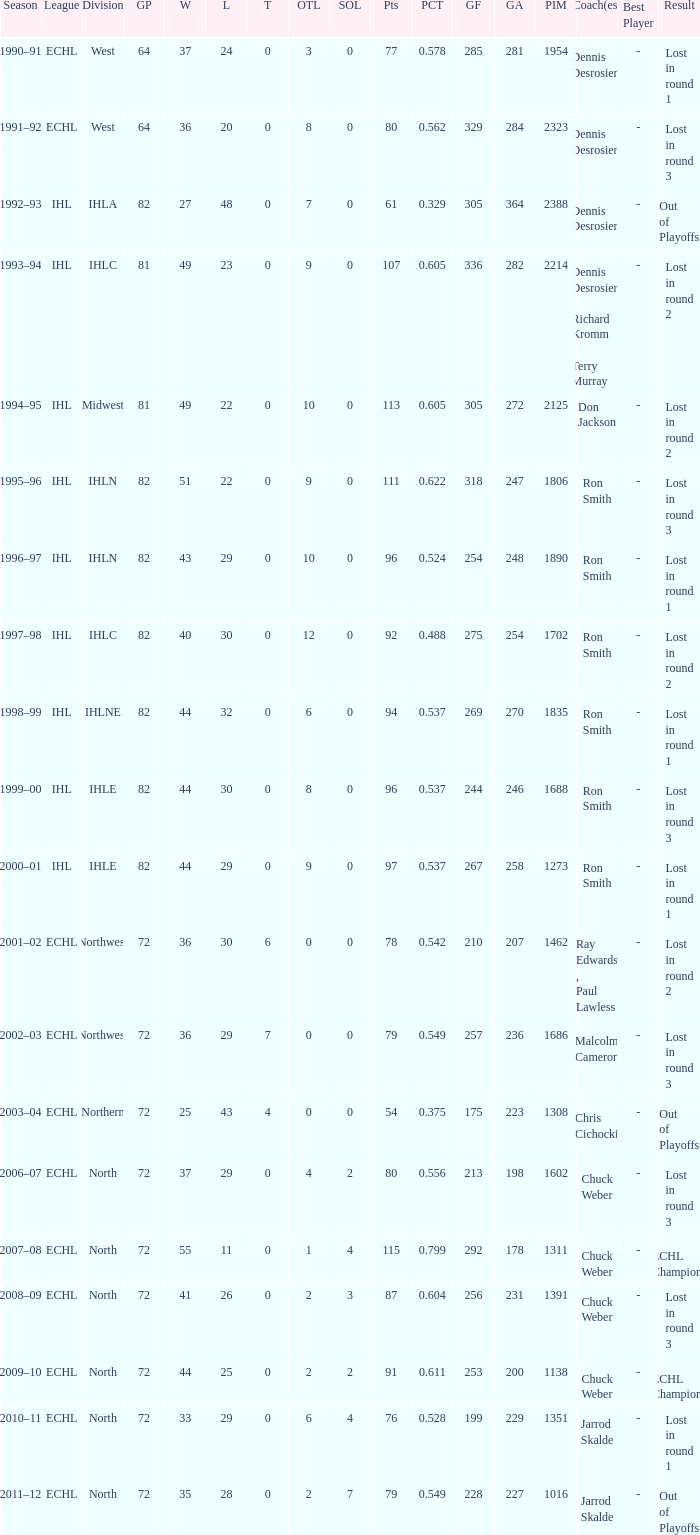What was the season where the team reached a GP of 244? 1999–00. 